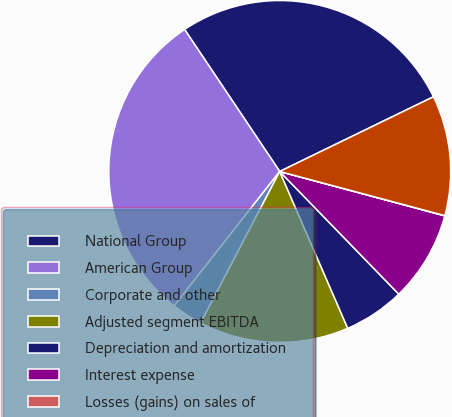<chart> <loc_0><loc_0><loc_500><loc_500><pie_chart><fcel>National Group<fcel>American Group<fcel>Corporate and other<fcel>Adjusted segment EBITDA<fcel>Depreciation and amortization<fcel>Interest expense<fcel>Losses (gains) on sales of<fcel>Income before income taxes<nl><fcel>27.2%<fcel>30.01%<fcel>2.94%<fcel>14.17%<fcel>5.75%<fcel>8.56%<fcel>0.02%<fcel>11.36%<nl></chart> 